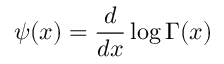<formula> <loc_0><loc_0><loc_500><loc_500>\psi ( x ) = \frac { d } { d x } \log \Gamma ( x )</formula> 